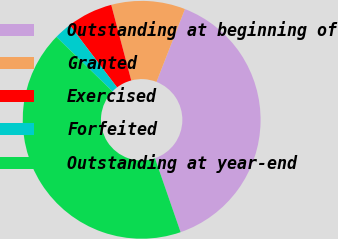Convert chart. <chart><loc_0><loc_0><loc_500><loc_500><pie_chart><fcel>Outstanding at beginning of<fcel>Granted<fcel>Exercised<fcel>Forfeited<fcel>Outstanding at year-end<nl><fcel>38.76%<fcel>10.05%<fcel>6.22%<fcel>2.38%<fcel>42.59%<nl></chart> 